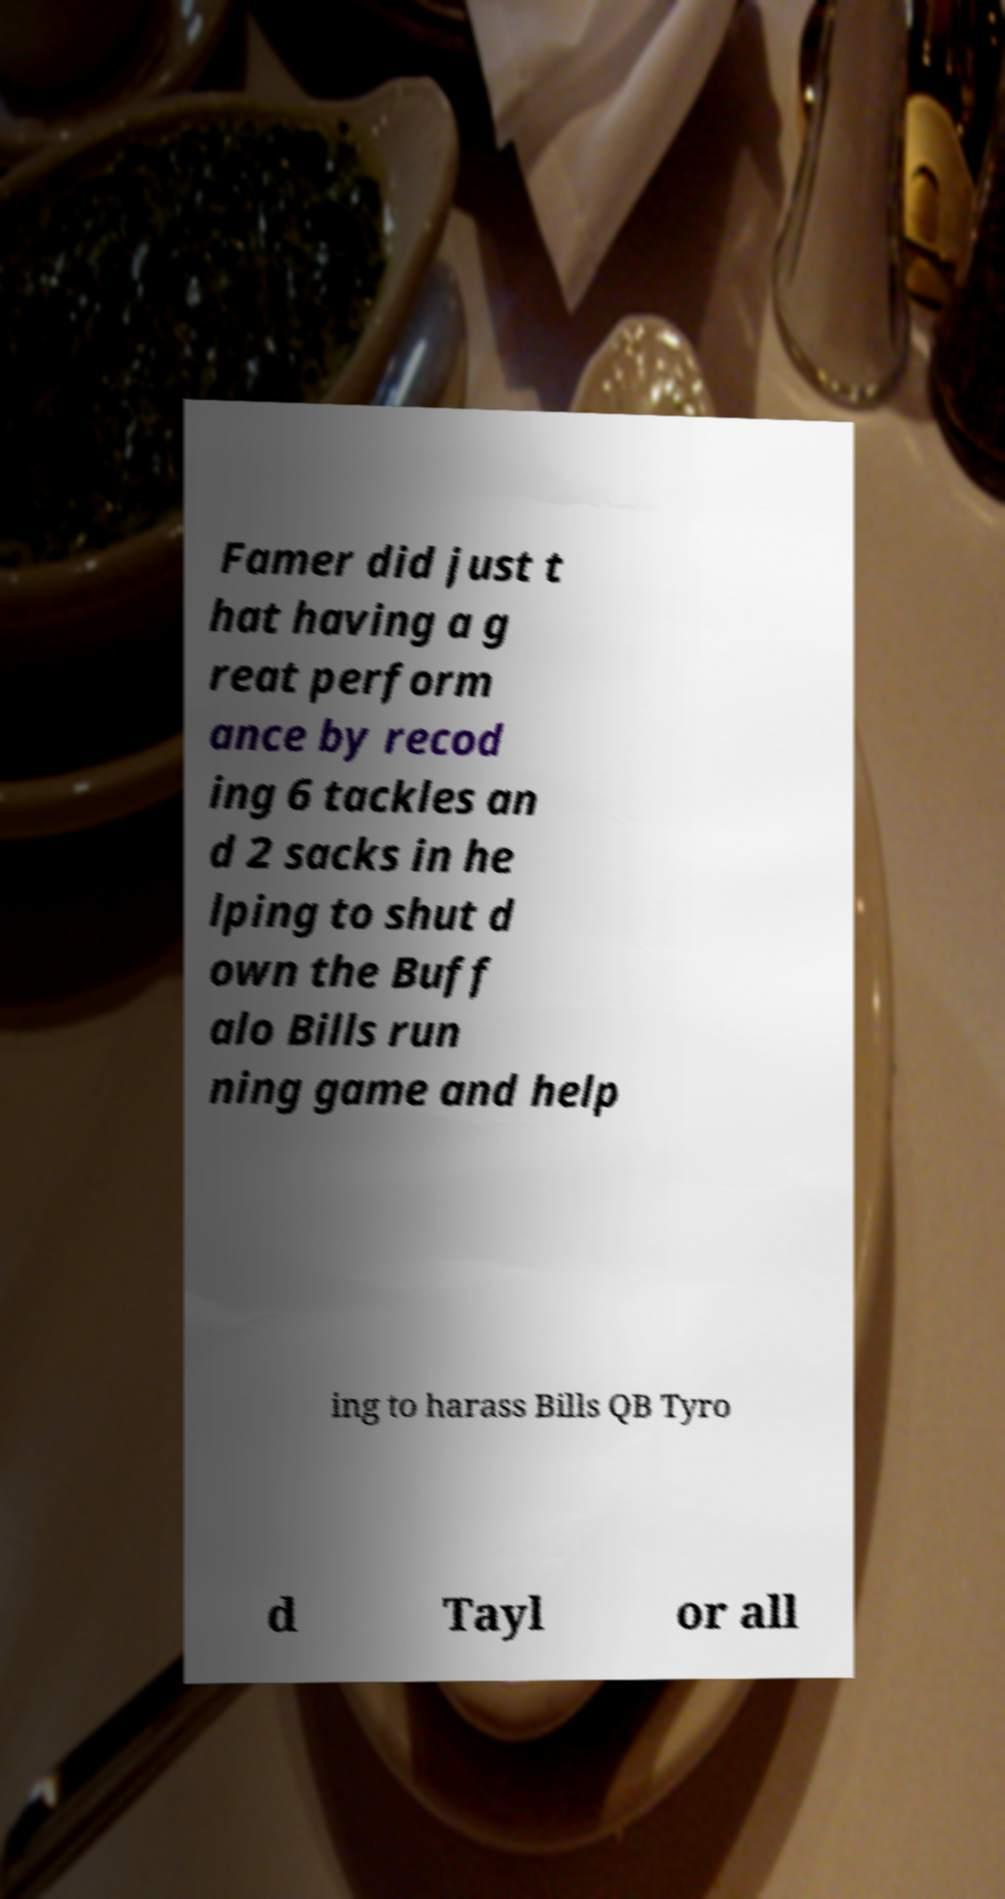I need the written content from this picture converted into text. Can you do that? Famer did just t hat having a g reat perform ance by recod ing 6 tackles an d 2 sacks in he lping to shut d own the Buff alo Bills run ning game and help ing to harass Bills QB Tyro d Tayl or all 